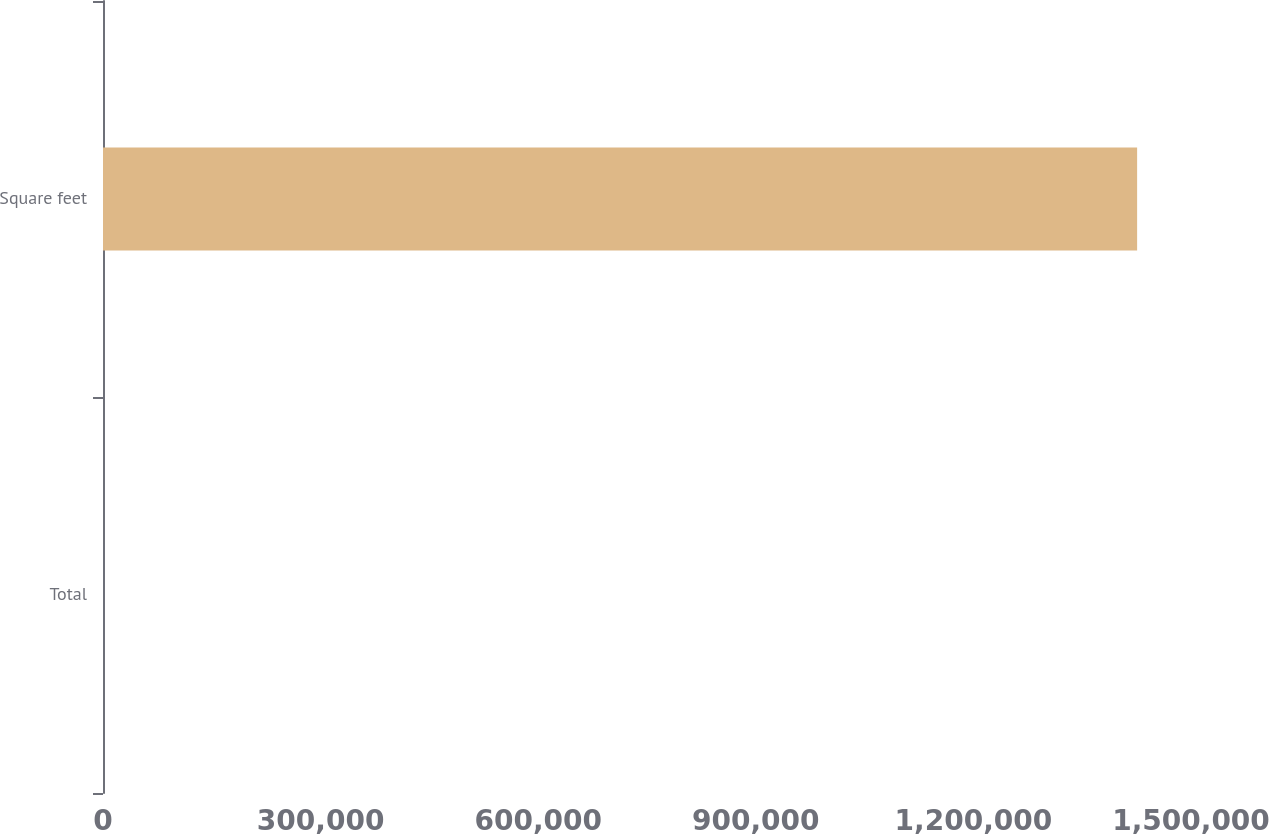<chart> <loc_0><loc_0><loc_500><loc_500><bar_chart><fcel>Total<fcel>Square feet<nl><fcel>14<fcel>1.42572e+06<nl></chart> 